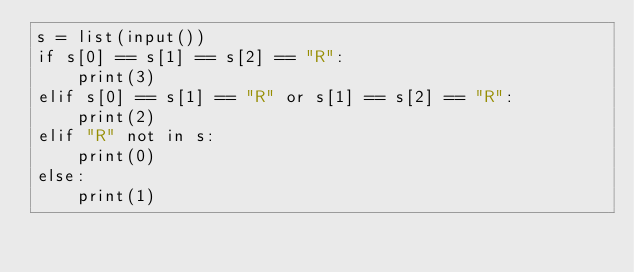<code> <loc_0><loc_0><loc_500><loc_500><_Python_>s = list(input())
if s[0] == s[1] == s[2] == "R":
    print(3)
elif s[0] == s[1] == "R" or s[1] == s[2] == "R":
    print(2)
elif "R" not in s:
    print(0)
else:
    print(1)</code> 